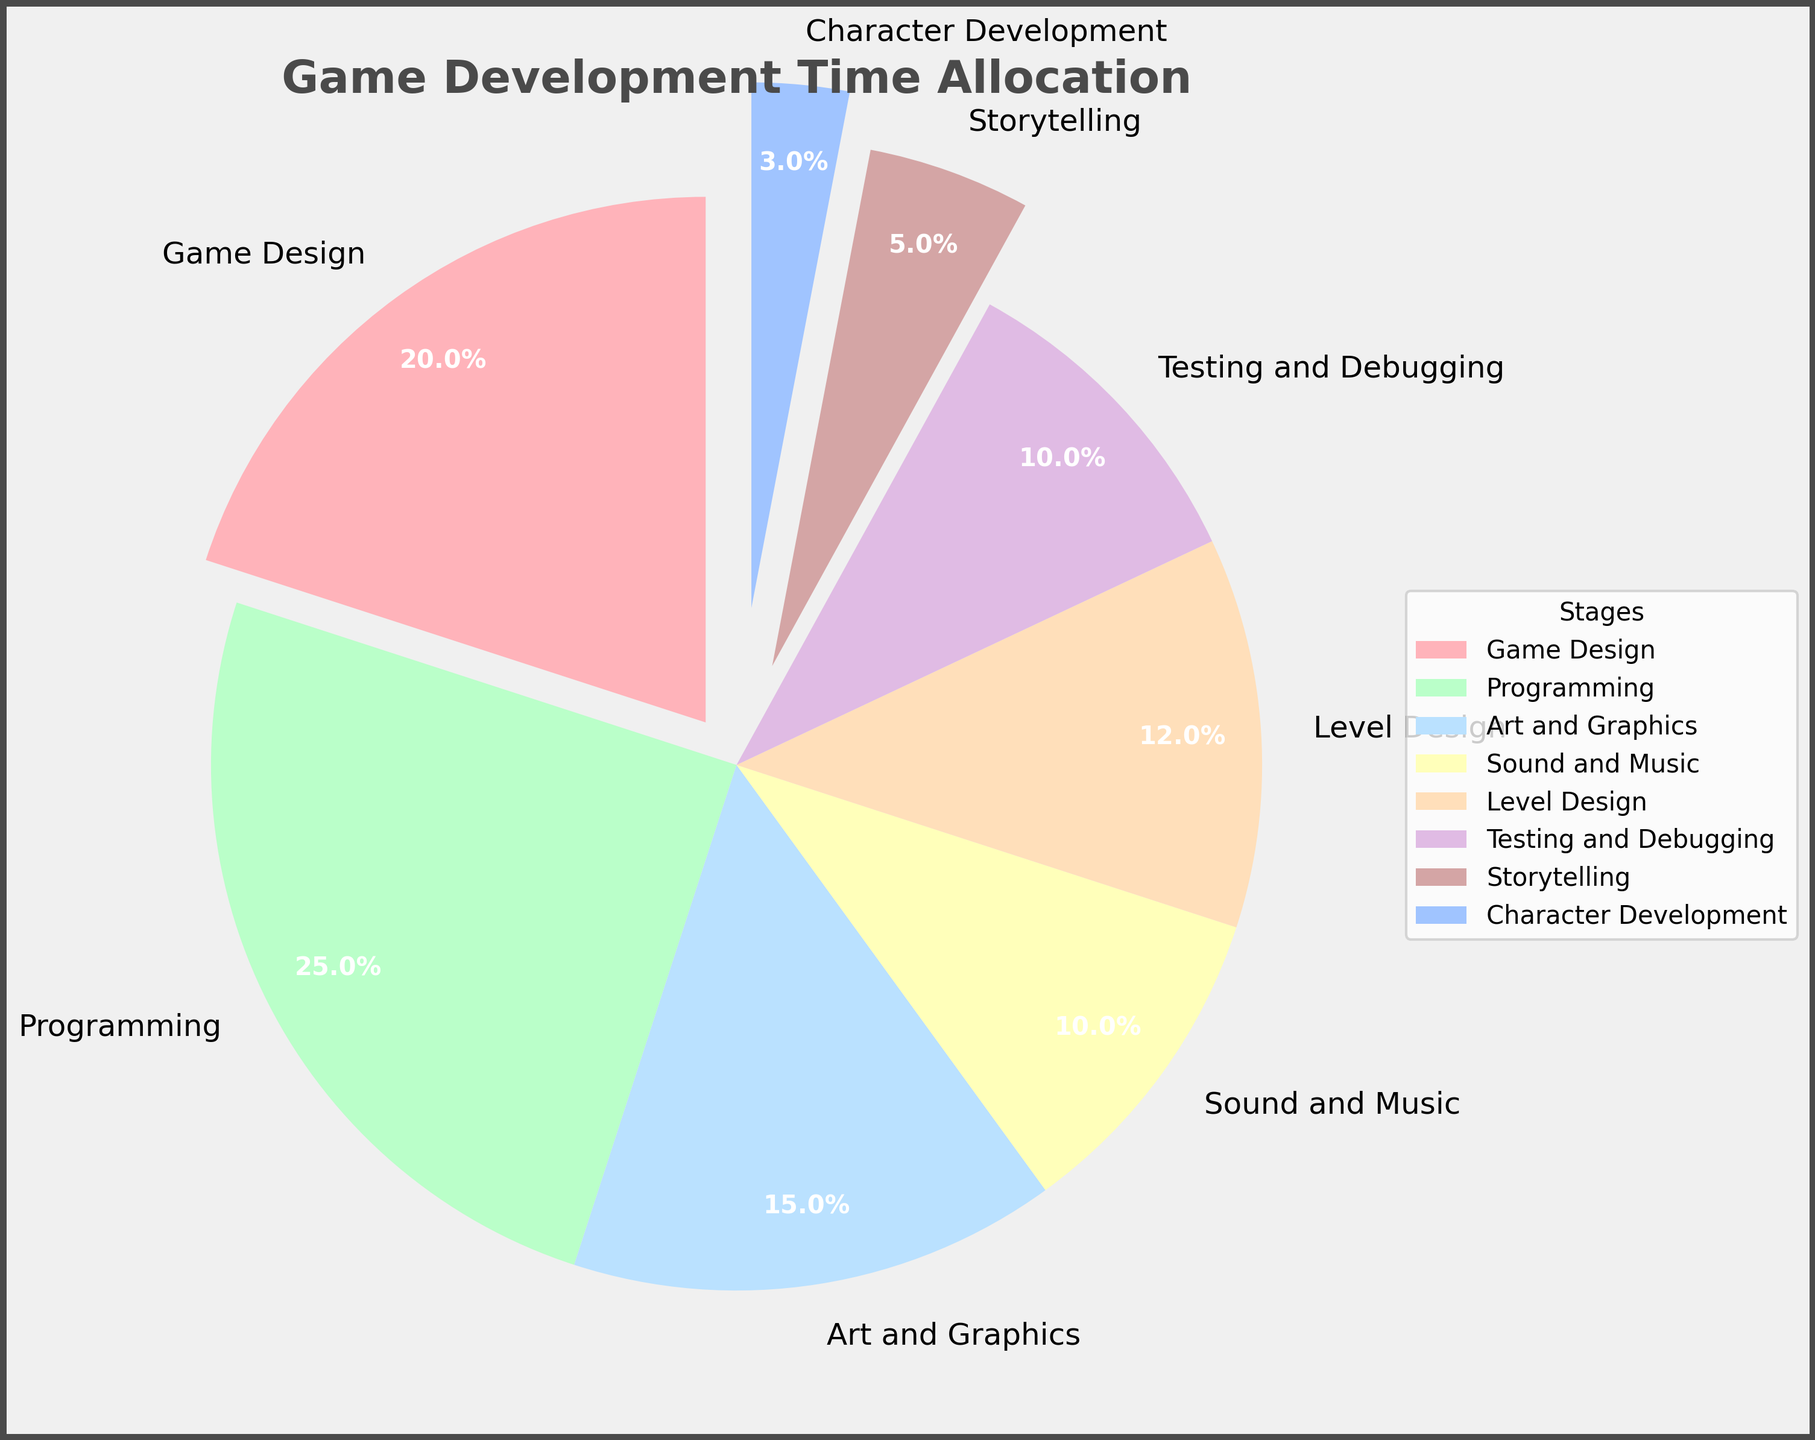Which stage has the highest percentage in the chart? The programming stage is the largest slice visible in the pie chart, indicating the highest percentage.
Answer: Programming Which stage requires more time: Art and Graphics or Level Design? By observing the pie chart, Art and Graphics has a slice of 15%, which is larger than Level Design's slice of 12%.
Answer: Art and Graphics What is the combined percentage of Storytelling and Character Development? Adding the percentages of Storytelling (5%) and Character Development (3%) gives a total of 8%.
Answer: 8% Which stage has a slice that explodes the most? By looking at the visual feature of the pie chart, Character Development is the slice that is exploded the most.
Answer: Character Development How much more percentage is spent on Programming compared to Testing and Debugging? Subtracting the percentage for Testing and Debugging (10%) from the Programming percentage (25%) gives 15%.
Answer: 15% If we sum the time allocated to Sound and Music, Level Design, and Storytelling, what is the total percentage? Adding the percentages of Sound and Music (10%), Level Design (12%), and Storytelling (5%) gives a total of 27%.
Answer: 27% Are the total percentages for Game Design and Testing and Debugging equal? By comparing their slices, Game Design is 20% and Testing and Debugging is 10%, so they are not equal.
Answer: No Is the percentage for Programming greater than the combined percentage for Storytelling and Character Development? Comparing the Programming percentage of 25% with the combined percentage of Storytelling and Character Development (8%), Programming is greater.
Answer: Yes Which stage has a bright blue color in its slice? The slice shaded in bright blue corresponds to Art and Graphics on the pie chart.
Answer: Art and Graphics What is the difference in percentage between Game Design and Sound and Music? Subtracting the percentage of Sound and Music (10%) from Game Design (20%) results in 10%.
Answer: 10% 